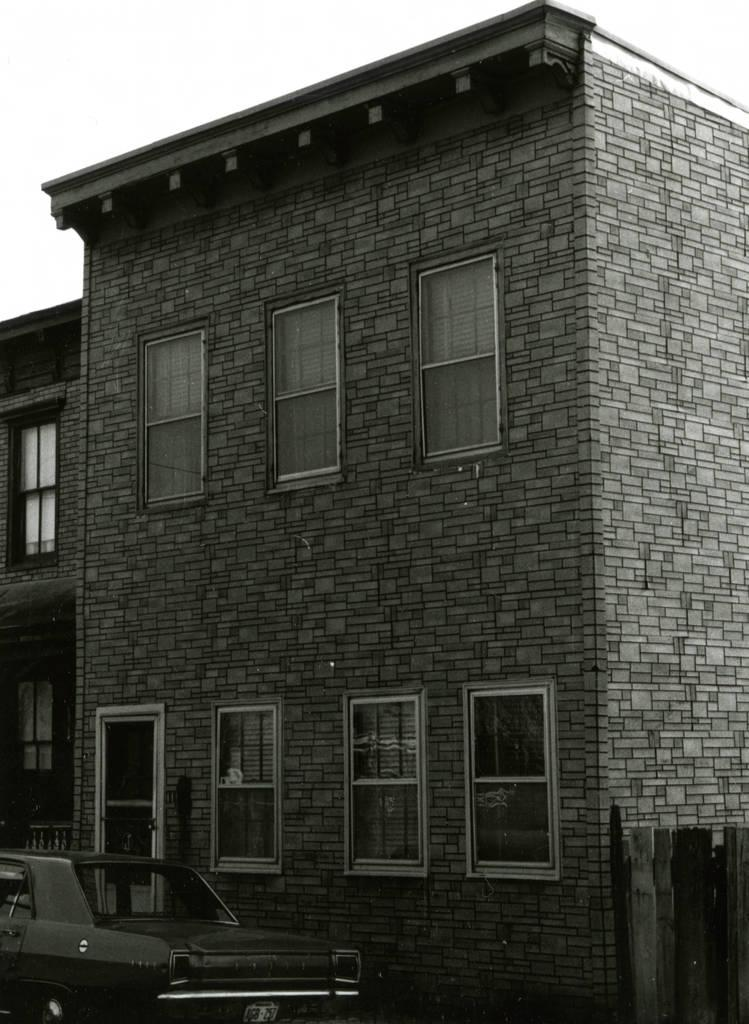What is located at the bottom of the image? There is a vehicle at the bottom of the image. What type of structure can be seen in the image? There is a building in the image. What features does the building have? The building has windows and doors. What is present on the right side of the image? There is a fence on the right side of the image. What can be seen in the background of the image? The sky is visible in the background of the image. Where can you find the best jeans in the market in the image? There is no reference to jeans, a market, or any shopping activity in the image. --- Facts: 1. There is a person holding a book in the image. 2. The person is sitting on a chair. 3. The chair has a cushion. 4. There is a table next to the chair. 5. The table has a lamp on it. Absurd Topics: elephant, ocean, bicycle Conversation: What is the person in the image holding? The person is holding a book in the image. What is the person sitting on? The person is sitting on a chair. What is special about the chair? The chair has a cushion. What is located next to the chair? There is a table next to the chair. What is on the table? The table has a lamp on it. Reasoning: Let's think step by step in order to produce the conversation. We start by identifying the main subject in the image, which is the person holding a book. Then, we expand the conversation to include other items that are also visible, such as the chair, cushion, table, and lamp. Each question is designed to elicit a specific detail about the image that is known from the provided facts. Absurd Question/Answer: Can you see an elephant swimming in the ocean in the image? No, there is no elephant or ocean present in the image. 